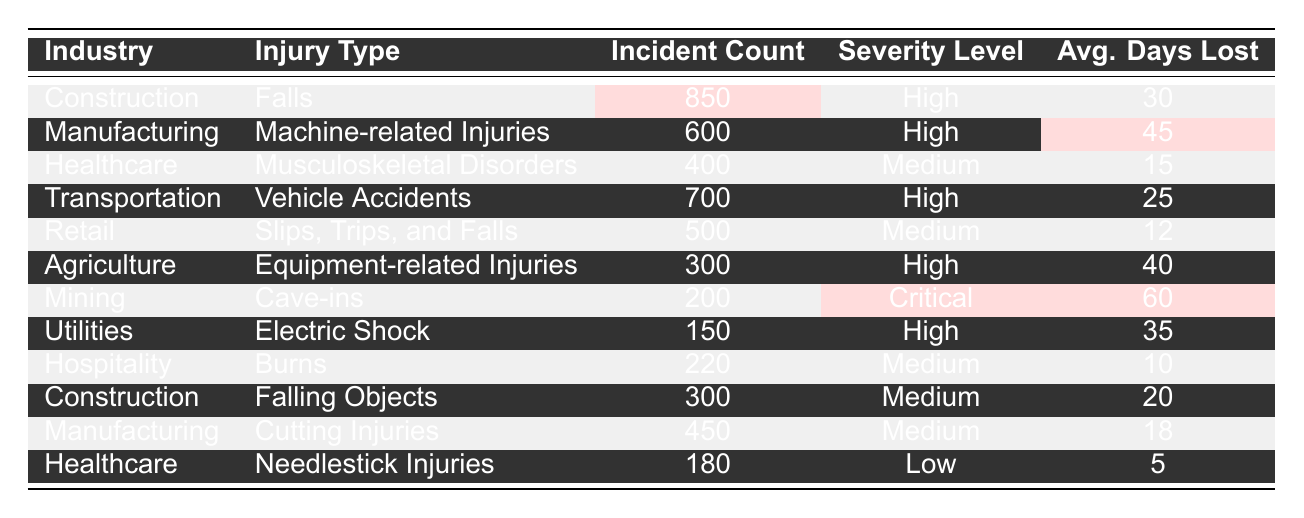What industry has the highest incident count? The incident counts for each industry are: Construction (850), Manufacturing (600), Healthcare (400), Transportation (700), Retail (500), Agriculture (300), Mining (200), Utilities (150), Hospitality (220). Among these, Construction has the highest incident count of 850.
Answer: Construction Which injury type has the lowest average days lost? The average days lost for each injury type are: Falls (30), Machine-related Injuries (45), Musculoskeletal Disorders (15), Vehicle Accidents (25), Slips, Trips, and Falls (12), Equipment-related Injuries (40), Cave-ins (60), Electric Shock (35), Burns (10), Falling Objects (20), Cutting Injuries (18), Needlestick Injuries (5). The lowest average days lost is for Needlestick Injuries at 5 days.
Answer: Needlestick Injuries What is the average incident count of injuries in the Healthcare industry? The incident counts for Healthcare injuries are: Musculoskeletal Disorders (400) and Needlestick Injuries (180). The average is calculated as (400 + 180) / 2 = 290.
Answer: 290 Is the severity level of Cave-ins higher than that of Slips, Trips, and Falls? The severity level of Cave-ins is Critical, while the severity level of Slips, Trips, and Falls is Medium. Since Critical is higher than Medium, the statement is true.
Answer: Yes What is the total incident count of all injuries across the Utility and Mining industries? The incident counts for Utilities and Mining are: Electric Shock (150) and Cave-ins (200). The total count is 150 + 200 = 350.
Answer: 350 Which injury type has the second highest incident count? The incident counts in descending order are: Falls (850), Vehicle Accidents (700), Machine-related Injuries (600), Slips, Trips, and Falls (500), and so on. The second highest incident count is for Vehicle Accidents with 700 incidents.
Answer: Vehicle Accidents What is the total average days lost for all industries combined? The average days lost for each injury type are: 30 (Falls), 45 (Machine-related Injuries), 15 (Musculoskeletal Disorders), 25 (Vehicle Accidents), 12 (Slips, Trips, and Falls), 40 (Equipment-related Injuries), 60 (Cave-ins), 35 (Electric Shock), 10 (Burns), 20 (Falling Objects), 18 (Cutting Injuries), 5 (Needlestick Injuries). Summing these gives 30 + 45 + 15 + 25 + 12 + 40 + 60 + 35 + 10 + 20 + 18 + 5 =  350 days. To find the average, we divide by the total number of incidents, which is 12: 350 / 12 = 29.17 days.
Answer: 29.17 Which industry has the least number of reported incidents in this table? The incident counts are as follows: Construction (850), Manufacturing (600), Healthcare (400), Transportation (700), Retail (500), Agriculture (300), Mining (200), Utilities (150), Hospitality (220). The lowest count is for Utilities with 150 incidents.
Answer: Utilities How do the average days lost for Machinery-related injuries compare to those for Needlestick injuries? The average days lost for Machine-related Injuries is 45, while for Needlestick Injuries it is 5. Therefore, 45 is significantly greater than 5, indicating that Machine-related Injuries cause longer average days lost.
Answer: Machine-related Injuries What is the total number of incidents attributed to the Construction industry? The Construction industry has two injury types: Falls (850) and Falling Objects (300). Adding these together gives 850 + 300 = 1150 incidents in total for the Construction industry.
Answer: 1150 